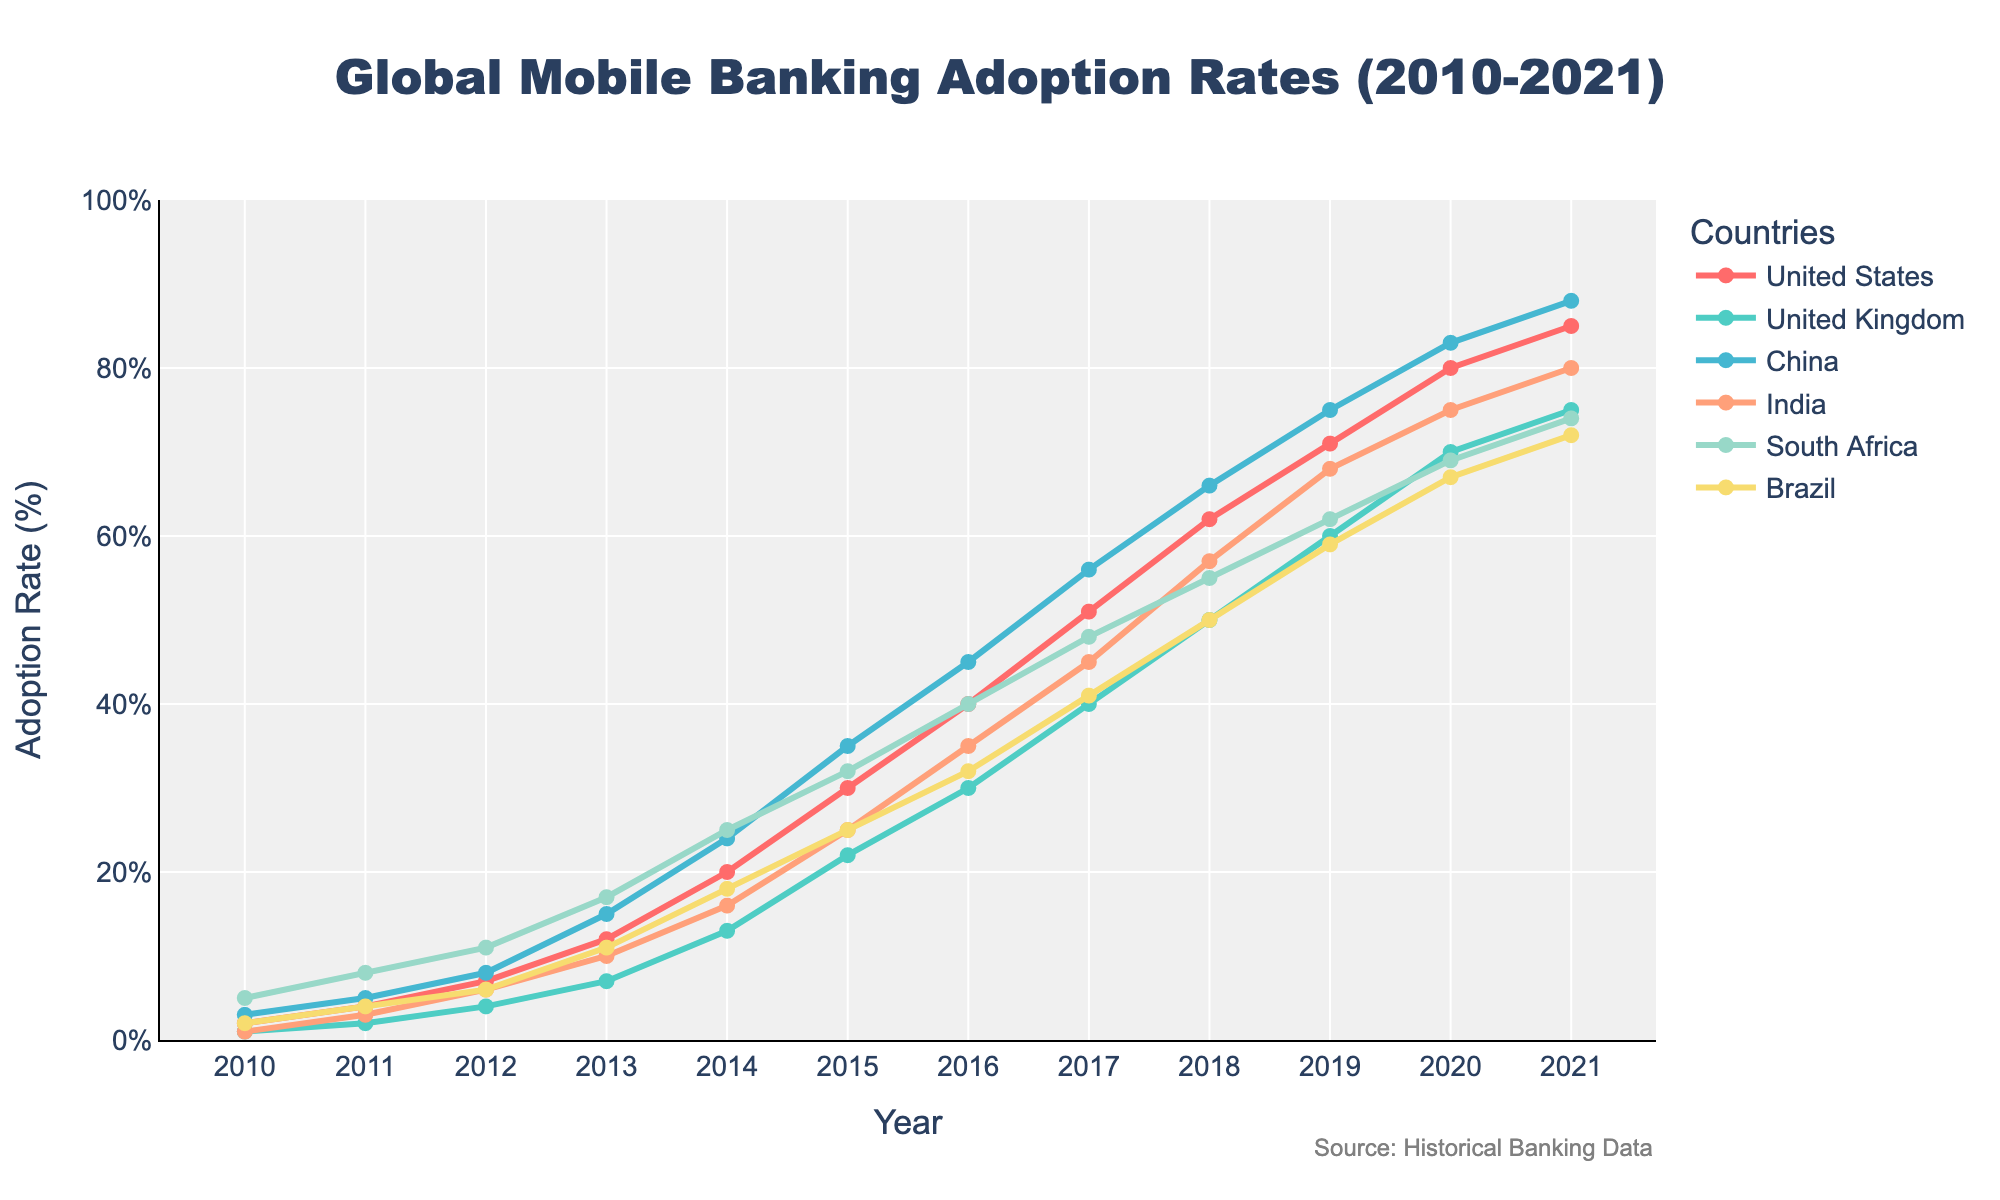What's the title of the plot? The title is located at the top center of the plot. It reads 'Global Mobile Banking Adoption Rates (2010-2021)'.
Answer: Global Mobile Banking Adoption Rates (2010-2021) Which country had the highest adoption rate in 2015? By looking at the markers and lines in the plot for the year 2015, we can see that the country with the highest adoption rate is China.
Answer: China How does the adoption rate of mobile banking in India in 2012 compare to that in 2020? To determine this, we look at the markers for India in the years 2012 and 2020. In 2012, the adoption rate was 6%, and in 2020, it was 75%. The difference is 75% - 6% = 69%.
Answer: 69% Between which consecutive years did the United States see the highest increase in adoption rates? We inspect the United States data series and calculate the yearly difference: 2010-2011 (2%), 2011-2012 (3%), 2012-2013 (5%), 2013-2014 (8%), 2014-2015 (10%), 2015-2016 (10%), 2016-2017 (11%), 2017-2018 (11%), 2018-2019 (9%), 2019-2020 (9%), 2020-2021 (5%). The highest increase happens between 2016 and 2017 (11%).
Answer: 2016-2017 What was the average adoption rate for Brazil over the time period? Sum the adoption rates for Brazil from 2010 to 2021 and divide by the number of years. (2+4+6+11+18+25+32+41+50+59+67+72) / 12 = 32.5%
Answer: 32.5% Which country had the lowest adoption rate in 2018? We compare the adoption rates for all the countries in 2018. The UK had the lowest rate at 50%.
Answer: United Kingdom Did South Africa always have a higher adoption rate than Brazil? For each year, compare South Africa's and Brazil's adoption rates. South Africa had higher rates than Brazil in each year from 2010 to 2021.
Answer: Yes What's the adoption trend in China from 2010 to 2021? Observing China's data series from 2010 to 2021, it is clear that the adoption rate increased steadily each year, moving from 3% to 88%.
Answer: Steadily increasing Which year saw India reaching an adoption rate of 57%? By finding 57% on the y-axis and tracing it to India’s data series, we see that this occurred in 2018.
Answer: 2018 Between 2010 and 2021, what was the largest single-year increase in adoption rate for any country, and which country experienced it? Inspect each country's data series year-by-year to find the largest single-year increase. In 2014-2015, the United States saw an increase of 10% (20% to 30%), which is matched by India which also increased by 9% in the same year.
Answer: United States, 2014-2015 or India, 2014-2015 